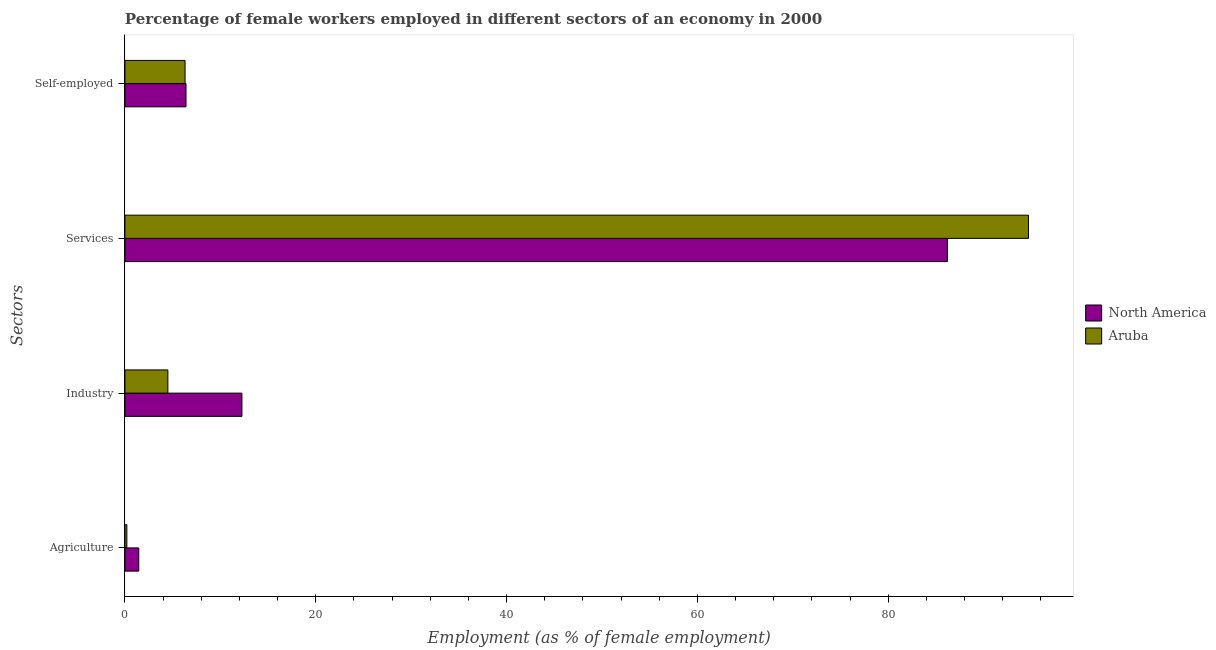How many groups of bars are there?
Make the answer very short. 4. Are the number of bars per tick equal to the number of legend labels?
Keep it short and to the point. Yes. Are the number of bars on each tick of the Y-axis equal?
Provide a succinct answer. Yes. How many bars are there on the 2nd tick from the top?
Offer a terse response. 2. What is the label of the 2nd group of bars from the top?
Provide a succinct answer. Services. What is the percentage of female workers in industry in North America?
Your answer should be compact. 12.26. Across all countries, what is the maximum percentage of self employed female workers?
Keep it short and to the point. 6.4. Across all countries, what is the minimum percentage of female workers in services?
Give a very brief answer. 86.2. In which country was the percentage of female workers in industry maximum?
Provide a short and direct response. North America. In which country was the percentage of female workers in services minimum?
Provide a succinct answer. North America. What is the total percentage of female workers in industry in the graph?
Give a very brief answer. 16.76. What is the difference between the percentage of female workers in services in Aruba and that in North America?
Your answer should be compact. 8.5. What is the difference between the percentage of female workers in services in Aruba and the percentage of self employed female workers in North America?
Provide a short and direct response. 88.3. What is the average percentage of female workers in agriculture per country?
Make the answer very short. 0.82. What is the difference between the percentage of female workers in industry and percentage of female workers in services in North America?
Provide a succinct answer. -73.94. What is the ratio of the percentage of female workers in services in Aruba to that in North America?
Your answer should be compact. 1.1. What is the difference between the highest and the second highest percentage of female workers in agriculture?
Your response must be concise. 1.25. What is the difference between the highest and the lowest percentage of female workers in agriculture?
Provide a short and direct response. 1.25. Is the sum of the percentage of self employed female workers in North America and Aruba greater than the maximum percentage of female workers in industry across all countries?
Your answer should be very brief. Yes. What does the 1st bar from the top in Industry represents?
Provide a succinct answer. Aruba. What does the 1st bar from the bottom in Services represents?
Your answer should be very brief. North America. Is it the case that in every country, the sum of the percentage of female workers in agriculture and percentage of female workers in industry is greater than the percentage of female workers in services?
Your answer should be compact. No. What is the difference between two consecutive major ticks on the X-axis?
Offer a very short reply. 20. Are the values on the major ticks of X-axis written in scientific E-notation?
Offer a terse response. No. Does the graph contain any zero values?
Offer a terse response. No. Does the graph contain grids?
Your answer should be compact. No. Where does the legend appear in the graph?
Offer a very short reply. Center right. How many legend labels are there?
Provide a succinct answer. 2. What is the title of the graph?
Make the answer very short. Percentage of female workers employed in different sectors of an economy in 2000. What is the label or title of the X-axis?
Ensure brevity in your answer.  Employment (as % of female employment). What is the label or title of the Y-axis?
Make the answer very short. Sectors. What is the Employment (as % of female employment) in North America in Agriculture?
Provide a short and direct response. 1.45. What is the Employment (as % of female employment) of Aruba in Agriculture?
Provide a short and direct response. 0.2. What is the Employment (as % of female employment) in North America in Industry?
Provide a short and direct response. 12.26. What is the Employment (as % of female employment) in North America in Services?
Give a very brief answer. 86.2. What is the Employment (as % of female employment) of Aruba in Services?
Provide a short and direct response. 94.7. What is the Employment (as % of female employment) of North America in Self-employed?
Ensure brevity in your answer.  6.4. What is the Employment (as % of female employment) in Aruba in Self-employed?
Offer a very short reply. 6.3. Across all Sectors, what is the maximum Employment (as % of female employment) of North America?
Offer a very short reply. 86.2. Across all Sectors, what is the maximum Employment (as % of female employment) of Aruba?
Provide a short and direct response. 94.7. Across all Sectors, what is the minimum Employment (as % of female employment) of North America?
Offer a terse response. 1.45. Across all Sectors, what is the minimum Employment (as % of female employment) in Aruba?
Offer a terse response. 0.2. What is the total Employment (as % of female employment) in North America in the graph?
Offer a very short reply. 106.31. What is the total Employment (as % of female employment) in Aruba in the graph?
Ensure brevity in your answer.  105.7. What is the difference between the Employment (as % of female employment) of North America in Agriculture and that in Industry?
Give a very brief answer. -10.81. What is the difference between the Employment (as % of female employment) of Aruba in Agriculture and that in Industry?
Your answer should be compact. -4.3. What is the difference between the Employment (as % of female employment) of North America in Agriculture and that in Services?
Provide a succinct answer. -84.75. What is the difference between the Employment (as % of female employment) in Aruba in Agriculture and that in Services?
Your answer should be compact. -94.5. What is the difference between the Employment (as % of female employment) in North America in Agriculture and that in Self-employed?
Give a very brief answer. -4.95. What is the difference between the Employment (as % of female employment) of North America in Industry and that in Services?
Provide a short and direct response. -73.94. What is the difference between the Employment (as % of female employment) of Aruba in Industry and that in Services?
Offer a very short reply. -90.2. What is the difference between the Employment (as % of female employment) of North America in Industry and that in Self-employed?
Your answer should be very brief. 5.86. What is the difference between the Employment (as % of female employment) of North America in Services and that in Self-employed?
Make the answer very short. 79.8. What is the difference between the Employment (as % of female employment) of Aruba in Services and that in Self-employed?
Provide a short and direct response. 88.4. What is the difference between the Employment (as % of female employment) of North America in Agriculture and the Employment (as % of female employment) of Aruba in Industry?
Your answer should be very brief. -3.05. What is the difference between the Employment (as % of female employment) of North America in Agriculture and the Employment (as % of female employment) of Aruba in Services?
Give a very brief answer. -93.25. What is the difference between the Employment (as % of female employment) in North America in Agriculture and the Employment (as % of female employment) in Aruba in Self-employed?
Offer a very short reply. -4.85. What is the difference between the Employment (as % of female employment) in North America in Industry and the Employment (as % of female employment) in Aruba in Services?
Offer a very short reply. -82.44. What is the difference between the Employment (as % of female employment) in North America in Industry and the Employment (as % of female employment) in Aruba in Self-employed?
Ensure brevity in your answer.  5.96. What is the difference between the Employment (as % of female employment) of North America in Services and the Employment (as % of female employment) of Aruba in Self-employed?
Provide a succinct answer. 79.9. What is the average Employment (as % of female employment) in North America per Sectors?
Provide a short and direct response. 26.58. What is the average Employment (as % of female employment) of Aruba per Sectors?
Offer a very short reply. 26.43. What is the difference between the Employment (as % of female employment) in North America and Employment (as % of female employment) in Aruba in Agriculture?
Your response must be concise. 1.25. What is the difference between the Employment (as % of female employment) of North America and Employment (as % of female employment) of Aruba in Industry?
Provide a short and direct response. 7.76. What is the difference between the Employment (as % of female employment) of North America and Employment (as % of female employment) of Aruba in Self-employed?
Offer a very short reply. 0.1. What is the ratio of the Employment (as % of female employment) of North America in Agriculture to that in Industry?
Keep it short and to the point. 0.12. What is the ratio of the Employment (as % of female employment) of Aruba in Agriculture to that in Industry?
Your answer should be compact. 0.04. What is the ratio of the Employment (as % of female employment) in North America in Agriculture to that in Services?
Offer a terse response. 0.02. What is the ratio of the Employment (as % of female employment) in Aruba in Agriculture to that in Services?
Ensure brevity in your answer.  0. What is the ratio of the Employment (as % of female employment) in North America in Agriculture to that in Self-employed?
Ensure brevity in your answer.  0.23. What is the ratio of the Employment (as % of female employment) in Aruba in Agriculture to that in Self-employed?
Give a very brief answer. 0.03. What is the ratio of the Employment (as % of female employment) of North America in Industry to that in Services?
Give a very brief answer. 0.14. What is the ratio of the Employment (as % of female employment) in Aruba in Industry to that in Services?
Provide a short and direct response. 0.05. What is the ratio of the Employment (as % of female employment) of North America in Industry to that in Self-employed?
Make the answer very short. 1.92. What is the ratio of the Employment (as % of female employment) in Aruba in Industry to that in Self-employed?
Give a very brief answer. 0.71. What is the ratio of the Employment (as % of female employment) in North America in Services to that in Self-employed?
Offer a very short reply. 13.47. What is the ratio of the Employment (as % of female employment) in Aruba in Services to that in Self-employed?
Make the answer very short. 15.03. What is the difference between the highest and the second highest Employment (as % of female employment) in North America?
Offer a terse response. 73.94. What is the difference between the highest and the second highest Employment (as % of female employment) in Aruba?
Give a very brief answer. 88.4. What is the difference between the highest and the lowest Employment (as % of female employment) of North America?
Provide a succinct answer. 84.75. What is the difference between the highest and the lowest Employment (as % of female employment) in Aruba?
Provide a succinct answer. 94.5. 